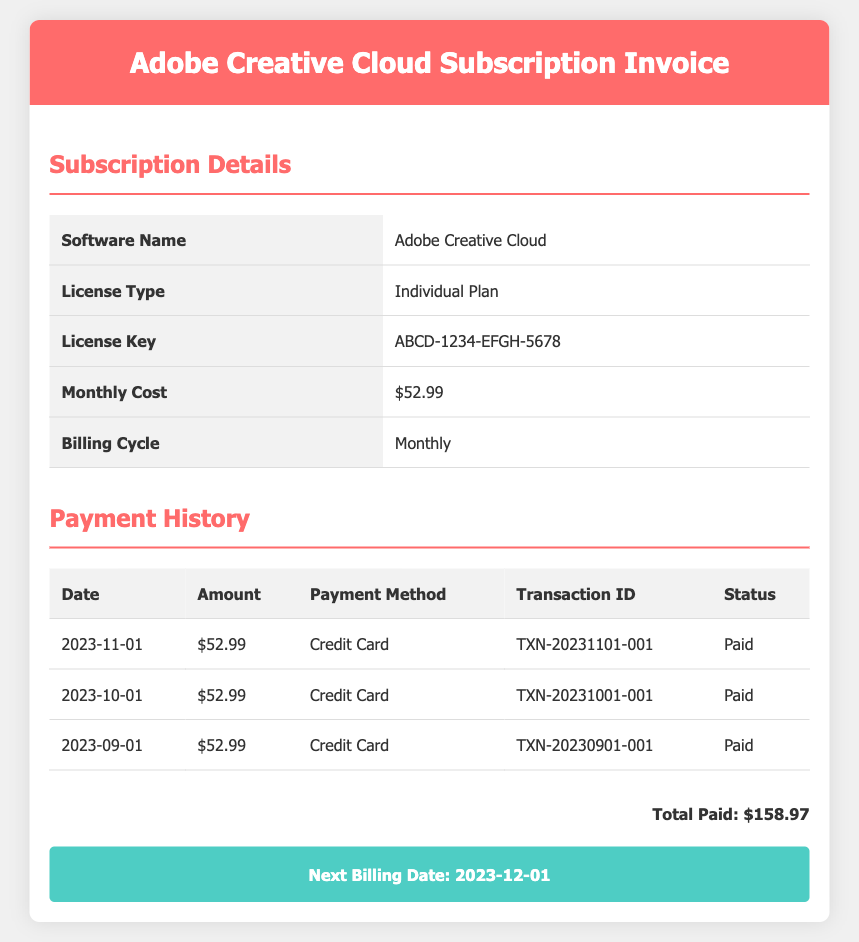What is the monthly cost of the subscription? The monthly cost is listed in the subscription details section of the document.
Answer: $52.99 What is the license key for the software? The license key is provided in the subscription details section of the document.
Answer: ABCD-1234-EFGH-5678 When is the next billing date? The next billing date is stated in the next billing section of the document.
Answer: 2023-12-01 What payment method was used for the payment on 2023-11-01? The payment method for the specified date can be found in the payment history table.
Answer: Credit Card How many payments have been made so far? The number of payments can be calculated from the rows in the payment history section.
Answer: 3 